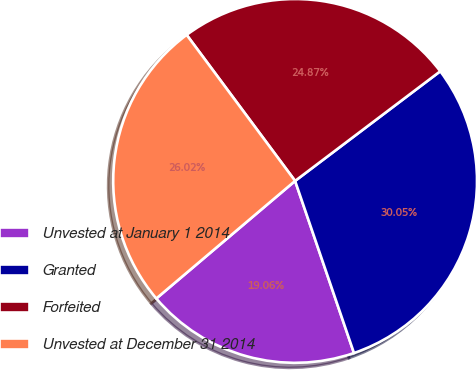<chart> <loc_0><loc_0><loc_500><loc_500><pie_chart><fcel>Unvested at January 1 2014<fcel>Granted<fcel>Forfeited<fcel>Unvested at December 31 2014<nl><fcel>19.06%<fcel>30.05%<fcel>24.87%<fcel>26.02%<nl></chart> 